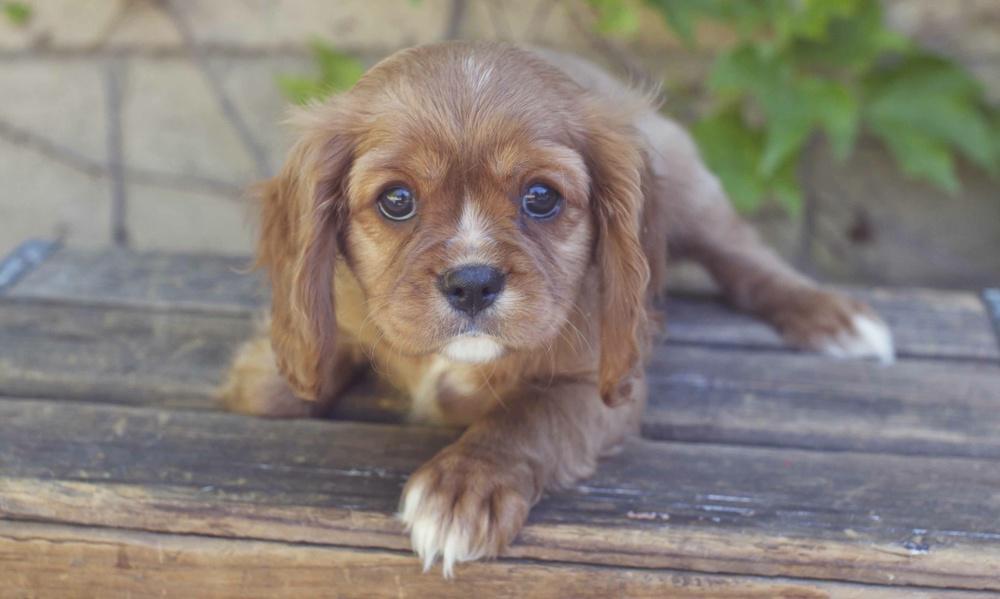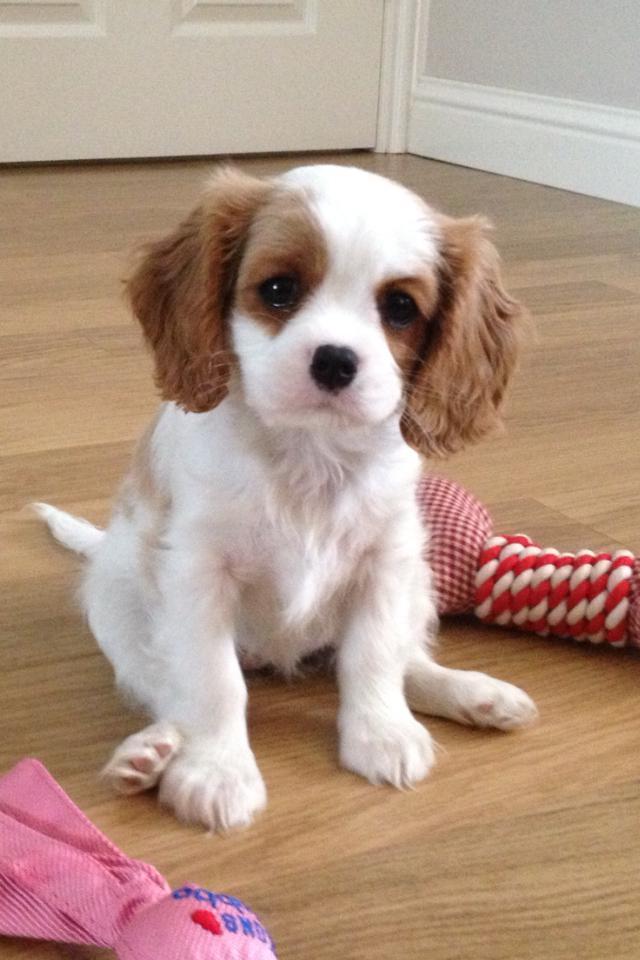The first image is the image on the left, the second image is the image on the right. Analyze the images presented: Is the assertion "A spaniel puppy is posed on its belly on wood planks, in one image." valid? Answer yes or no. Yes. 